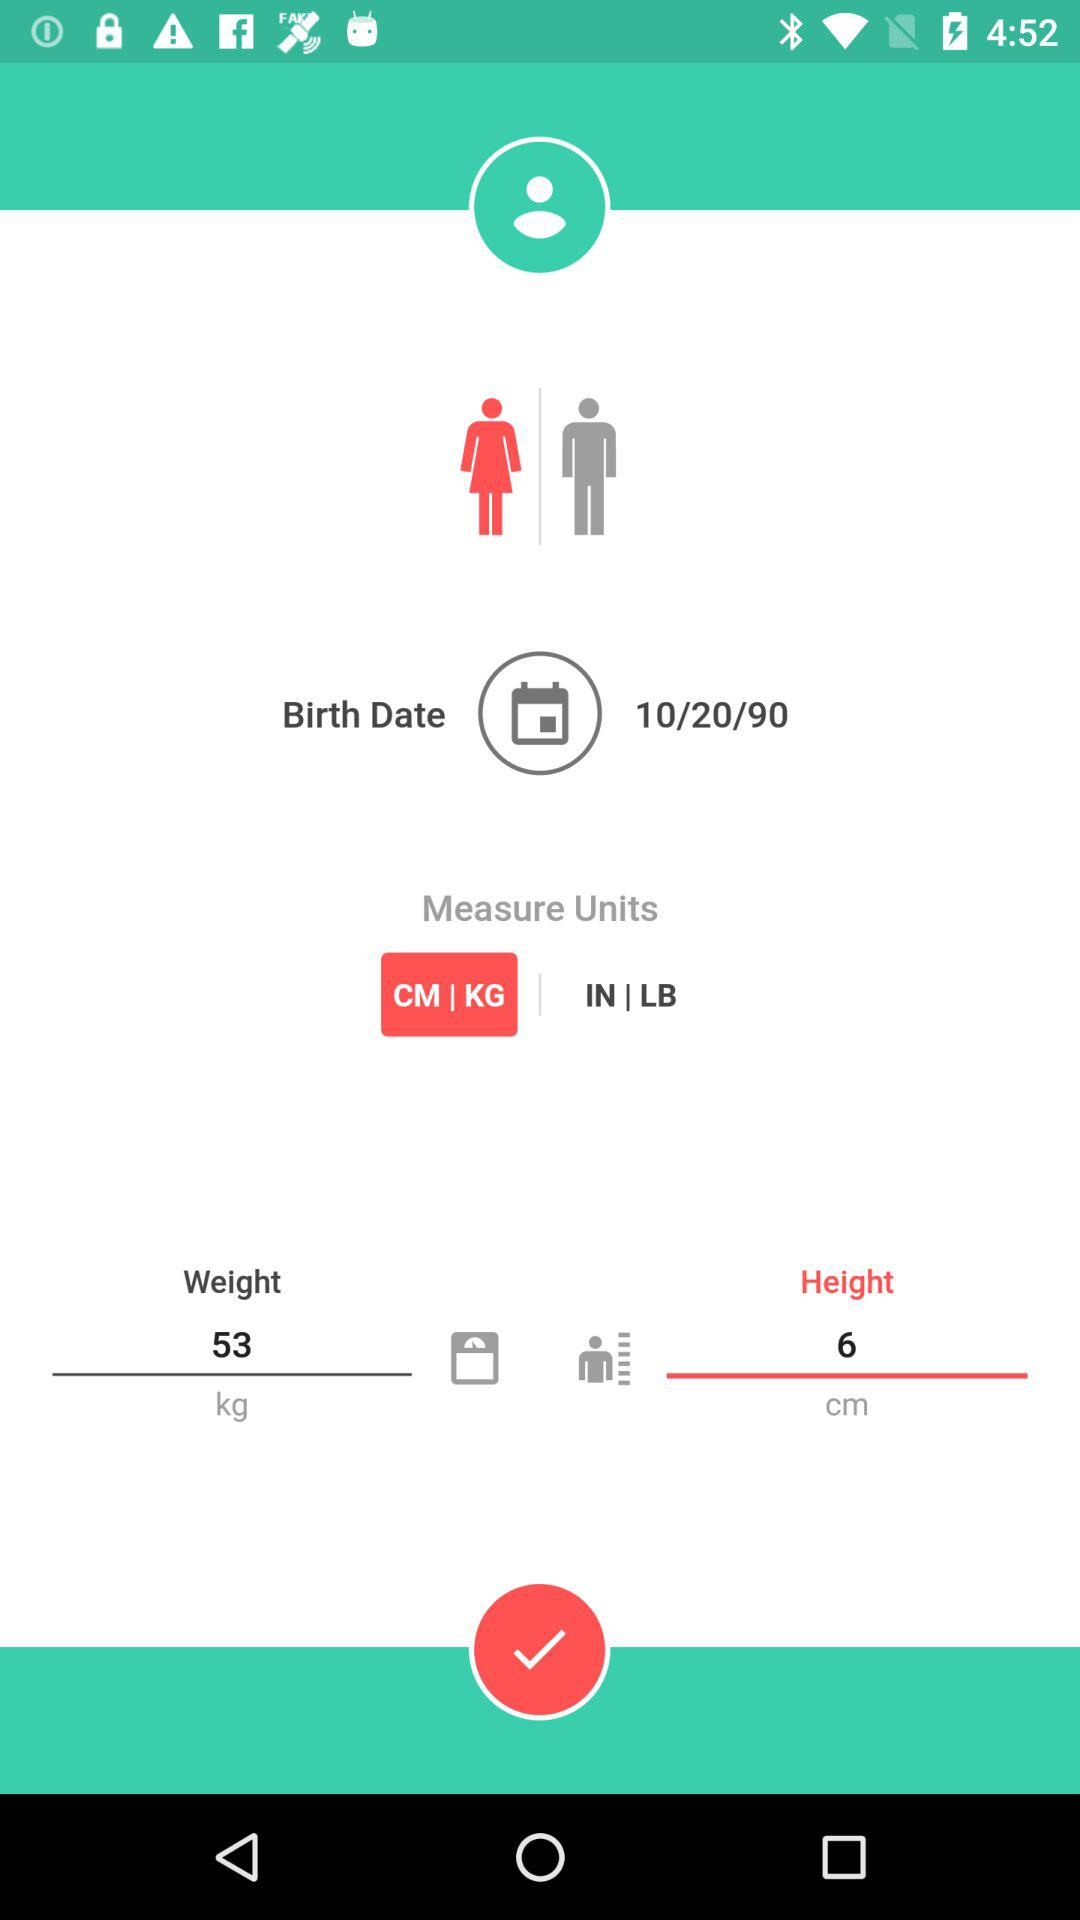What is the weight? The weight is 53 kg. 